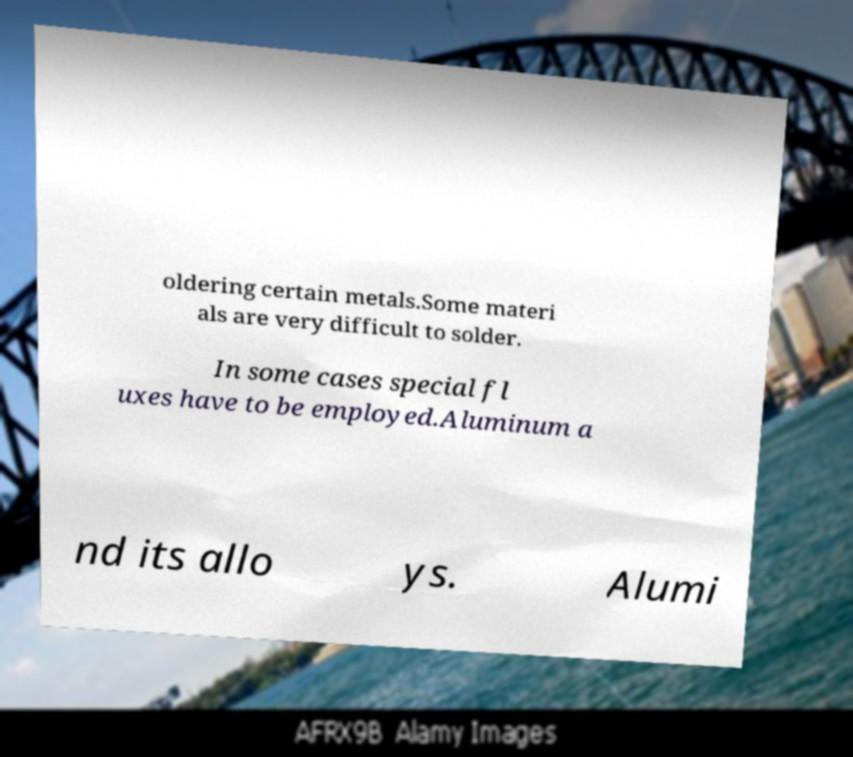I need the written content from this picture converted into text. Can you do that? oldering certain metals.Some materi als are very difficult to solder. In some cases special fl uxes have to be employed.Aluminum a nd its allo ys. Alumi 